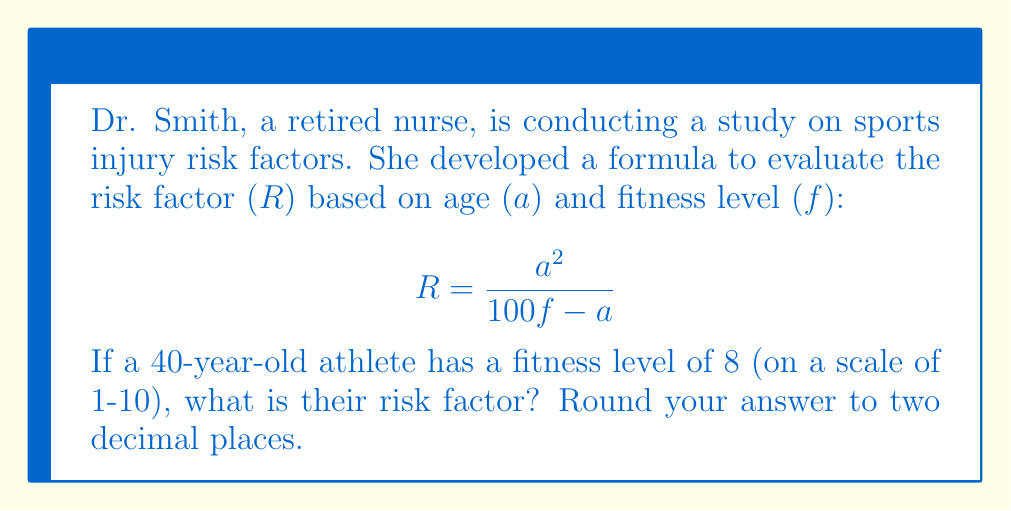Give your solution to this math problem. Let's approach this step-by-step:

1) We are given:
   - Age (a) = 40 years
   - Fitness level (f) = 8 (on a scale of 1-10)

2) We need to substitute these values into the formula:

   $$ R = \frac{a^2}{100f - a} $$

3) Substituting the values:

   $$ R = \frac{40^2}{100(8) - 40} $$

4) Let's simplify the numerator first:
   
   $$ R = \frac{1600}{100(8) - 40} $$

5) Now, let's simplify the denominator:

   $$ R = \frac{1600}{800 - 40} = \frac{1600}{760} $$

6) Dividing 1600 by 760:

   $$ R \approx 2.1052631578947368 $$

7) Rounding to two decimal places:

   $$ R \approx 2.11 $$
Answer: 2.11 